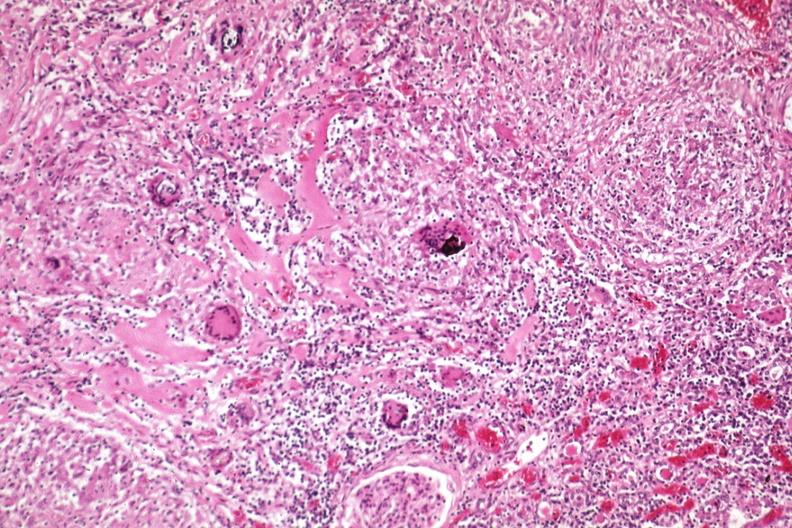what is present?
Answer the question using a single word or phrase. Sarcoidosis 